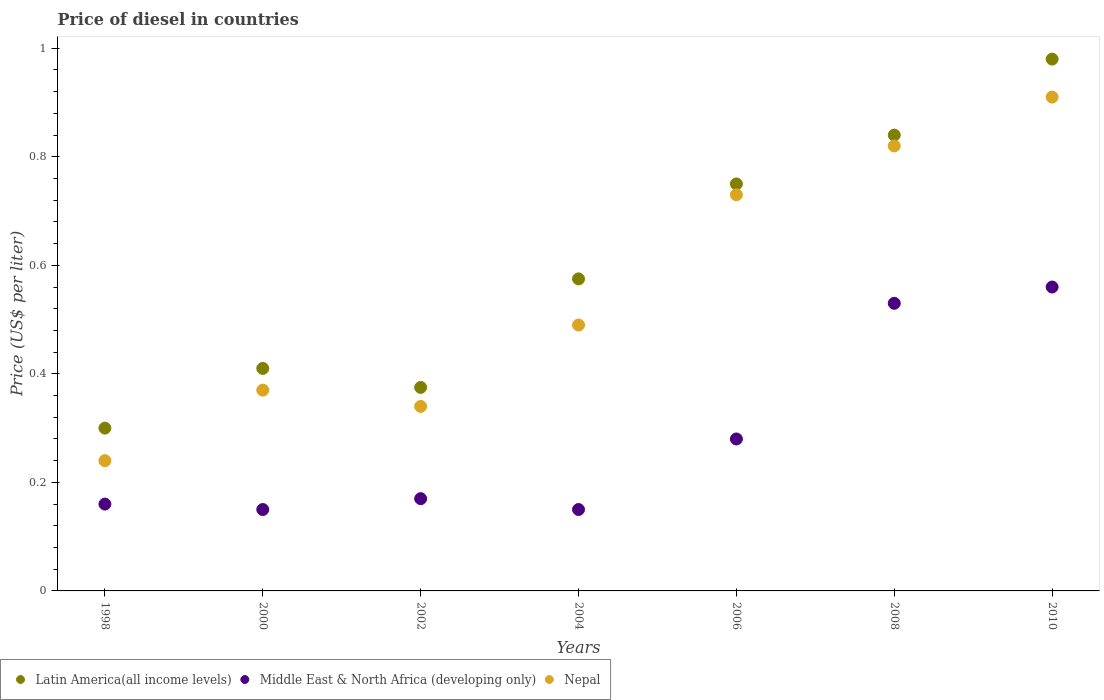How many different coloured dotlines are there?
Give a very brief answer. 3. What is the price of diesel in Middle East & North Africa (developing only) in 2002?
Make the answer very short. 0.17. Across all years, what is the maximum price of diesel in Nepal?
Keep it short and to the point. 0.91. Across all years, what is the minimum price of diesel in Middle East & North Africa (developing only)?
Your answer should be very brief. 0.15. What is the total price of diesel in Latin America(all income levels) in the graph?
Keep it short and to the point. 4.23. What is the difference between the price of diesel in Nepal in 2004 and that in 2006?
Your response must be concise. -0.24. What is the difference between the price of diesel in Middle East & North Africa (developing only) in 2006 and the price of diesel in Nepal in 2000?
Your answer should be very brief. -0.09. What is the average price of diesel in Middle East & North Africa (developing only) per year?
Your answer should be compact. 0.29. In the year 2010, what is the difference between the price of diesel in Middle East & North Africa (developing only) and price of diesel in Latin America(all income levels)?
Ensure brevity in your answer.  -0.42. In how many years, is the price of diesel in Latin America(all income levels) greater than 0.9600000000000001 US$?
Provide a short and direct response. 1. What is the ratio of the price of diesel in Latin America(all income levels) in 1998 to that in 2000?
Give a very brief answer. 0.73. Is the difference between the price of diesel in Middle East & North Africa (developing only) in 2000 and 2008 greater than the difference between the price of diesel in Latin America(all income levels) in 2000 and 2008?
Make the answer very short. Yes. What is the difference between the highest and the second highest price of diesel in Nepal?
Your response must be concise. 0.09. What is the difference between the highest and the lowest price of diesel in Nepal?
Give a very brief answer. 0.67. In how many years, is the price of diesel in Middle East & North Africa (developing only) greater than the average price of diesel in Middle East & North Africa (developing only) taken over all years?
Your response must be concise. 2. How many dotlines are there?
Make the answer very short. 3. Are the values on the major ticks of Y-axis written in scientific E-notation?
Your response must be concise. No. Does the graph contain any zero values?
Offer a very short reply. No. How are the legend labels stacked?
Give a very brief answer. Horizontal. What is the title of the graph?
Your answer should be compact. Price of diesel in countries. What is the label or title of the Y-axis?
Offer a terse response. Price (US$ per liter). What is the Price (US$ per liter) in Latin America(all income levels) in 1998?
Provide a short and direct response. 0.3. What is the Price (US$ per liter) of Middle East & North Africa (developing only) in 1998?
Provide a succinct answer. 0.16. What is the Price (US$ per liter) of Nepal in 1998?
Offer a very short reply. 0.24. What is the Price (US$ per liter) in Latin America(all income levels) in 2000?
Provide a succinct answer. 0.41. What is the Price (US$ per liter) in Nepal in 2000?
Ensure brevity in your answer.  0.37. What is the Price (US$ per liter) of Middle East & North Africa (developing only) in 2002?
Provide a short and direct response. 0.17. What is the Price (US$ per liter) of Nepal in 2002?
Give a very brief answer. 0.34. What is the Price (US$ per liter) of Latin America(all income levels) in 2004?
Your answer should be very brief. 0.57. What is the Price (US$ per liter) in Middle East & North Africa (developing only) in 2004?
Ensure brevity in your answer.  0.15. What is the Price (US$ per liter) of Nepal in 2004?
Offer a very short reply. 0.49. What is the Price (US$ per liter) of Latin America(all income levels) in 2006?
Make the answer very short. 0.75. What is the Price (US$ per liter) of Middle East & North Africa (developing only) in 2006?
Give a very brief answer. 0.28. What is the Price (US$ per liter) in Nepal in 2006?
Offer a very short reply. 0.73. What is the Price (US$ per liter) in Latin America(all income levels) in 2008?
Give a very brief answer. 0.84. What is the Price (US$ per liter) in Middle East & North Africa (developing only) in 2008?
Ensure brevity in your answer.  0.53. What is the Price (US$ per liter) of Nepal in 2008?
Make the answer very short. 0.82. What is the Price (US$ per liter) in Middle East & North Africa (developing only) in 2010?
Offer a very short reply. 0.56. What is the Price (US$ per liter) of Nepal in 2010?
Your answer should be compact. 0.91. Across all years, what is the maximum Price (US$ per liter) of Middle East & North Africa (developing only)?
Provide a succinct answer. 0.56. Across all years, what is the maximum Price (US$ per liter) of Nepal?
Your answer should be compact. 0.91. Across all years, what is the minimum Price (US$ per liter) of Latin America(all income levels)?
Your answer should be very brief. 0.3. Across all years, what is the minimum Price (US$ per liter) of Middle East & North Africa (developing only)?
Give a very brief answer. 0.15. Across all years, what is the minimum Price (US$ per liter) in Nepal?
Your answer should be very brief. 0.24. What is the total Price (US$ per liter) in Latin America(all income levels) in the graph?
Offer a very short reply. 4.23. What is the difference between the Price (US$ per liter) in Latin America(all income levels) in 1998 and that in 2000?
Provide a short and direct response. -0.11. What is the difference between the Price (US$ per liter) in Middle East & North Africa (developing only) in 1998 and that in 2000?
Provide a succinct answer. 0.01. What is the difference between the Price (US$ per liter) of Nepal in 1998 and that in 2000?
Your answer should be very brief. -0.13. What is the difference between the Price (US$ per liter) of Latin America(all income levels) in 1998 and that in 2002?
Offer a terse response. -0.07. What is the difference between the Price (US$ per liter) in Middle East & North Africa (developing only) in 1998 and that in 2002?
Your answer should be compact. -0.01. What is the difference between the Price (US$ per liter) of Latin America(all income levels) in 1998 and that in 2004?
Offer a very short reply. -0.28. What is the difference between the Price (US$ per liter) of Nepal in 1998 and that in 2004?
Offer a very short reply. -0.25. What is the difference between the Price (US$ per liter) in Latin America(all income levels) in 1998 and that in 2006?
Keep it short and to the point. -0.45. What is the difference between the Price (US$ per liter) in Middle East & North Africa (developing only) in 1998 and that in 2006?
Your answer should be compact. -0.12. What is the difference between the Price (US$ per liter) of Nepal in 1998 and that in 2006?
Provide a short and direct response. -0.49. What is the difference between the Price (US$ per liter) in Latin America(all income levels) in 1998 and that in 2008?
Keep it short and to the point. -0.54. What is the difference between the Price (US$ per liter) in Middle East & North Africa (developing only) in 1998 and that in 2008?
Offer a terse response. -0.37. What is the difference between the Price (US$ per liter) in Nepal in 1998 and that in 2008?
Give a very brief answer. -0.58. What is the difference between the Price (US$ per liter) in Latin America(all income levels) in 1998 and that in 2010?
Provide a succinct answer. -0.68. What is the difference between the Price (US$ per liter) in Middle East & North Africa (developing only) in 1998 and that in 2010?
Offer a very short reply. -0.4. What is the difference between the Price (US$ per liter) in Nepal in 1998 and that in 2010?
Keep it short and to the point. -0.67. What is the difference between the Price (US$ per liter) of Latin America(all income levels) in 2000 and that in 2002?
Your response must be concise. 0.04. What is the difference between the Price (US$ per liter) of Middle East & North Africa (developing only) in 2000 and that in 2002?
Provide a succinct answer. -0.02. What is the difference between the Price (US$ per liter) of Nepal in 2000 and that in 2002?
Offer a terse response. 0.03. What is the difference between the Price (US$ per liter) of Latin America(all income levels) in 2000 and that in 2004?
Make the answer very short. -0.17. What is the difference between the Price (US$ per liter) in Middle East & North Africa (developing only) in 2000 and that in 2004?
Offer a very short reply. 0. What is the difference between the Price (US$ per liter) of Nepal in 2000 and that in 2004?
Give a very brief answer. -0.12. What is the difference between the Price (US$ per liter) in Latin America(all income levels) in 2000 and that in 2006?
Ensure brevity in your answer.  -0.34. What is the difference between the Price (US$ per liter) in Middle East & North Africa (developing only) in 2000 and that in 2006?
Your answer should be very brief. -0.13. What is the difference between the Price (US$ per liter) in Nepal in 2000 and that in 2006?
Offer a terse response. -0.36. What is the difference between the Price (US$ per liter) in Latin America(all income levels) in 2000 and that in 2008?
Offer a terse response. -0.43. What is the difference between the Price (US$ per liter) of Middle East & North Africa (developing only) in 2000 and that in 2008?
Offer a very short reply. -0.38. What is the difference between the Price (US$ per liter) of Nepal in 2000 and that in 2008?
Offer a very short reply. -0.45. What is the difference between the Price (US$ per liter) of Latin America(all income levels) in 2000 and that in 2010?
Your response must be concise. -0.57. What is the difference between the Price (US$ per liter) in Middle East & North Africa (developing only) in 2000 and that in 2010?
Ensure brevity in your answer.  -0.41. What is the difference between the Price (US$ per liter) of Nepal in 2000 and that in 2010?
Provide a succinct answer. -0.54. What is the difference between the Price (US$ per liter) in Middle East & North Africa (developing only) in 2002 and that in 2004?
Offer a very short reply. 0.02. What is the difference between the Price (US$ per liter) in Nepal in 2002 and that in 2004?
Give a very brief answer. -0.15. What is the difference between the Price (US$ per liter) in Latin America(all income levels) in 2002 and that in 2006?
Provide a succinct answer. -0.38. What is the difference between the Price (US$ per liter) in Middle East & North Africa (developing only) in 2002 and that in 2006?
Offer a terse response. -0.11. What is the difference between the Price (US$ per liter) in Nepal in 2002 and that in 2006?
Provide a short and direct response. -0.39. What is the difference between the Price (US$ per liter) in Latin America(all income levels) in 2002 and that in 2008?
Provide a short and direct response. -0.47. What is the difference between the Price (US$ per liter) of Middle East & North Africa (developing only) in 2002 and that in 2008?
Offer a terse response. -0.36. What is the difference between the Price (US$ per liter) in Nepal in 2002 and that in 2008?
Your response must be concise. -0.48. What is the difference between the Price (US$ per liter) in Latin America(all income levels) in 2002 and that in 2010?
Make the answer very short. -0.6. What is the difference between the Price (US$ per liter) of Middle East & North Africa (developing only) in 2002 and that in 2010?
Keep it short and to the point. -0.39. What is the difference between the Price (US$ per liter) in Nepal in 2002 and that in 2010?
Provide a succinct answer. -0.57. What is the difference between the Price (US$ per liter) of Latin America(all income levels) in 2004 and that in 2006?
Your answer should be very brief. -0.17. What is the difference between the Price (US$ per liter) in Middle East & North Africa (developing only) in 2004 and that in 2006?
Your response must be concise. -0.13. What is the difference between the Price (US$ per liter) in Nepal in 2004 and that in 2006?
Give a very brief answer. -0.24. What is the difference between the Price (US$ per liter) in Latin America(all income levels) in 2004 and that in 2008?
Your answer should be very brief. -0.27. What is the difference between the Price (US$ per liter) in Middle East & North Africa (developing only) in 2004 and that in 2008?
Ensure brevity in your answer.  -0.38. What is the difference between the Price (US$ per liter) in Nepal in 2004 and that in 2008?
Keep it short and to the point. -0.33. What is the difference between the Price (US$ per liter) in Latin America(all income levels) in 2004 and that in 2010?
Your answer should be compact. -0.41. What is the difference between the Price (US$ per liter) of Middle East & North Africa (developing only) in 2004 and that in 2010?
Offer a very short reply. -0.41. What is the difference between the Price (US$ per liter) of Nepal in 2004 and that in 2010?
Offer a terse response. -0.42. What is the difference between the Price (US$ per liter) of Latin America(all income levels) in 2006 and that in 2008?
Give a very brief answer. -0.09. What is the difference between the Price (US$ per liter) of Nepal in 2006 and that in 2008?
Your answer should be compact. -0.09. What is the difference between the Price (US$ per liter) of Latin America(all income levels) in 2006 and that in 2010?
Provide a succinct answer. -0.23. What is the difference between the Price (US$ per liter) of Middle East & North Africa (developing only) in 2006 and that in 2010?
Your response must be concise. -0.28. What is the difference between the Price (US$ per liter) of Nepal in 2006 and that in 2010?
Your answer should be very brief. -0.18. What is the difference between the Price (US$ per liter) in Latin America(all income levels) in 2008 and that in 2010?
Offer a terse response. -0.14. What is the difference between the Price (US$ per liter) in Middle East & North Africa (developing only) in 2008 and that in 2010?
Provide a succinct answer. -0.03. What is the difference between the Price (US$ per liter) in Nepal in 2008 and that in 2010?
Offer a very short reply. -0.09. What is the difference between the Price (US$ per liter) in Latin America(all income levels) in 1998 and the Price (US$ per liter) in Nepal in 2000?
Make the answer very short. -0.07. What is the difference between the Price (US$ per liter) of Middle East & North Africa (developing only) in 1998 and the Price (US$ per liter) of Nepal in 2000?
Provide a short and direct response. -0.21. What is the difference between the Price (US$ per liter) of Latin America(all income levels) in 1998 and the Price (US$ per liter) of Middle East & North Africa (developing only) in 2002?
Make the answer very short. 0.13. What is the difference between the Price (US$ per liter) in Latin America(all income levels) in 1998 and the Price (US$ per liter) in Nepal in 2002?
Ensure brevity in your answer.  -0.04. What is the difference between the Price (US$ per liter) in Middle East & North Africa (developing only) in 1998 and the Price (US$ per liter) in Nepal in 2002?
Your answer should be compact. -0.18. What is the difference between the Price (US$ per liter) of Latin America(all income levels) in 1998 and the Price (US$ per liter) of Nepal in 2004?
Your answer should be very brief. -0.19. What is the difference between the Price (US$ per liter) in Middle East & North Africa (developing only) in 1998 and the Price (US$ per liter) in Nepal in 2004?
Provide a succinct answer. -0.33. What is the difference between the Price (US$ per liter) of Latin America(all income levels) in 1998 and the Price (US$ per liter) of Nepal in 2006?
Make the answer very short. -0.43. What is the difference between the Price (US$ per liter) in Middle East & North Africa (developing only) in 1998 and the Price (US$ per liter) in Nepal in 2006?
Provide a succinct answer. -0.57. What is the difference between the Price (US$ per liter) of Latin America(all income levels) in 1998 and the Price (US$ per liter) of Middle East & North Africa (developing only) in 2008?
Give a very brief answer. -0.23. What is the difference between the Price (US$ per liter) of Latin America(all income levels) in 1998 and the Price (US$ per liter) of Nepal in 2008?
Offer a terse response. -0.52. What is the difference between the Price (US$ per liter) in Middle East & North Africa (developing only) in 1998 and the Price (US$ per liter) in Nepal in 2008?
Ensure brevity in your answer.  -0.66. What is the difference between the Price (US$ per liter) in Latin America(all income levels) in 1998 and the Price (US$ per liter) in Middle East & North Africa (developing only) in 2010?
Offer a terse response. -0.26. What is the difference between the Price (US$ per liter) of Latin America(all income levels) in 1998 and the Price (US$ per liter) of Nepal in 2010?
Keep it short and to the point. -0.61. What is the difference between the Price (US$ per liter) in Middle East & North Africa (developing only) in 1998 and the Price (US$ per liter) in Nepal in 2010?
Give a very brief answer. -0.75. What is the difference between the Price (US$ per liter) of Latin America(all income levels) in 2000 and the Price (US$ per liter) of Middle East & North Africa (developing only) in 2002?
Your answer should be compact. 0.24. What is the difference between the Price (US$ per liter) of Latin America(all income levels) in 2000 and the Price (US$ per liter) of Nepal in 2002?
Give a very brief answer. 0.07. What is the difference between the Price (US$ per liter) in Middle East & North Africa (developing only) in 2000 and the Price (US$ per liter) in Nepal in 2002?
Make the answer very short. -0.19. What is the difference between the Price (US$ per liter) of Latin America(all income levels) in 2000 and the Price (US$ per liter) of Middle East & North Africa (developing only) in 2004?
Offer a terse response. 0.26. What is the difference between the Price (US$ per liter) of Latin America(all income levels) in 2000 and the Price (US$ per liter) of Nepal in 2004?
Offer a very short reply. -0.08. What is the difference between the Price (US$ per liter) of Middle East & North Africa (developing only) in 2000 and the Price (US$ per liter) of Nepal in 2004?
Your answer should be compact. -0.34. What is the difference between the Price (US$ per liter) in Latin America(all income levels) in 2000 and the Price (US$ per liter) in Middle East & North Africa (developing only) in 2006?
Offer a terse response. 0.13. What is the difference between the Price (US$ per liter) in Latin America(all income levels) in 2000 and the Price (US$ per liter) in Nepal in 2006?
Make the answer very short. -0.32. What is the difference between the Price (US$ per liter) of Middle East & North Africa (developing only) in 2000 and the Price (US$ per liter) of Nepal in 2006?
Your answer should be very brief. -0.58. What is the difference between the Price (US$ per liter) in Latin America(all income levels) in 2000 and the Price (US$ per liter) in Middle East & North Africa (developing only) in 2008?
Your answer should be compact. -0.12. What is the difference between the Price (US$ per liter) in Latin America(all income levels) in 2000 and the Price (US$ per liter) in Nepal in 2008?
Your answer should be compact. -0.41. What is the difference between the Price (US$ per liter) of Middle East & North Africa (developing only) in 2000 and the Price (US$ per liter) of Nepal in 2008?
Make the answer very short. -0.67. What is the difference between the Price (US$ per liter) in Latin America(all income levels) in 2000 and the Price (US$ per liter) in Nepal in 2010?
Offer a very short reply. -0.5. What is the difference between the Price (US$ per liter) in Middle East & North Africa (developing only) in 2000 and the Price (US$ per liter) in Nepal in 2010?
Your answer should be very brief. -0.76. What is the difference between the Price (US$ per liter) of Latin America(all income levels) in 2002 and the Price (US$ per liter) of Middle East & North Africa (developing only) in 2004?
Offer a very short reply. 0.23. What is the difference between the Price (US$ per liter) of Latin America(all income levels) in 2002 and the Price (US$ per liter) of Nepal in 2004?
Make the answer very short. -0.12. What is the difference between the Price (US$ per liter) in Middle East & North Africa (developing only) in 2002 and the Price (US$ per liter) in Nepal in 2004?
Offer a very short reply. -0.32. What is the difference between the Price (US$ per liter) of Latin America(all income levels) in 2002 and the Price (US$ per liter) of Middle East & North Africa (developing only) in 2006?
Give a very brief answer. 0.1. What is the difference between the Price (US$ per liter) in Latin America(all income levels) in 2002 and the Price (US$ per liter) in Nepal in 2006?
Provide a short and direct response. -0.35. What is the difference between the Price (US$ per liter) in Middle East & North Africa (developing only) in 2002 and the Price (US$ per liter) in Nepal in 2006?
Provide a succinct answer. -0.56. What is the difference between the Price (US$ per liter) of Latin America(all income levels) in 2002 and the Price (US$ per liter) of Middle East & North Africa (developing only) in 2008?
Offer a very short reply. -0.15. What is the difference between the Price (US$ per liter) in Latin America(all income levels) in 2002 and the Price (US$ per liter) in Nepal in 2008?
Give a very brief answer. -0.45. What is the difference between the Price (US$ per liter) of Middle East & North Africa (developing only) in 2002 and the Price (US$ per liter) of Nepal in 2008?
Your answer should be compact. -0.65. What is the difference between the Price (US$ per liter) of Latin America(all income levels) in 2002 and the Price (US$ per liter) of Middle East & North Africa (developing only) in 2010?
Provide a succinct answer. -0.18. What is the difference between the Price (US$ per liter) in Latin America(all income levels) in 2002 and the Price (US$ per liter) in Nepal in 2010?
Ensure brevity in your answer.  -0.54. What is the difference between the Price (US$ per liter) in Middle East & North Africa (developing only) in 2002 and the Price (US$ per liter) in Nepal in 2010?
Ensure brevity in your answer.  -0.74. What is the difference between the Price (US$ per liter) in Latin America(all income levels) in 2004 and the Price (US$ per liter) in Middle East & North Africa (developing only) in 2006?
Your answer should be compact. 0.29. What is the difference between the Price (US$ per liter) of Latin America(all income levels) in 2004 and the Price (US$ per liter) of Nepal in 2006?
Offer a terse response. -0.15. What is the difference between the Price (US$ per liter) of Middle East & North Africa (developing only) in 2004 and the Price (US$ per liter) of Nepal in 2006?
Offer a terse response. -0.58. What is the difference between the Price (US$ per liter) in Latin America(all income levels) in 2004 and the Price (US$ per liter) in Middle East & North Africa (developing only) in 2008?
Give a very brief answer. 0.04. What is the difference between the Price (US$ per liter) of Latin America(all income levels) in 2004 and the Price (US$ per liter) of Nepal in 2008?
Your answer should be very brief. -0.24. What is the difference between the Price (US$ per liter) in Middle East & North Africa (developing only) in 2004 and the Price (US$ per liter) in Nepal in 2008?
Provide a succinct answer. -0.67. What is the difference between the Price (US$ per liter) in Latin America(all income levels) in 2004 and the Price (US$ per liter) in Middle East & North Africa (developing only) in 2010?
Make the answer very short. 0.01. What is the difference between the Price (US$ per liter) of Latin America(all income levels) in 2004 and the Price (US$ per liter) of Nepal in 2010?
Offer a very short reply. -0.34. What is the difference between the Price (US$ per liter) of Middle East & North Africa (developing only) in 2004 and the Price (US$ per liter) of Nepal in 2010?
Ensure brevity in your answer.  -0.76. What is the difference between the Price (US$ per liter) of Latin America(all income levels) in 2006 and the Price (US$ per liter) of Middle East & North Africa (developing only) in 2008?
Your answer should be compact. 0.22. What is the difference between the Price (US$ per liter) in Latin America(all income levels) in 2006 and the Price (US$ per liter) in Nepal in 2008?
Make the answer very short. -0.07. What is the difference between the Price (US$ per liter) of Middle East & North Africa (developing only) in 2006 and the Price (US$ per liter) of Nepal in 2008?
Ensure brevity in your answer.  -0.54. What is the difference between the Price (US$ per liter) in Latin America(all income levels) in 2006 and the Price (US$ per liter) in Middle East & North Africa (developing only) in 2010?
Ensure brevity in your answer.  0.19. What is the difference between the Price (US$ per liter) in Latin America(all income levels) in 2006 and the Price (US$ per liter) in Nepal in 2010?
Offer a very short reply. -0.16. What is the difference between the Price (US$ per liter) of Middle East & North Africa (developing only) in 2006 and the Price (US$ per liter) of Nepal in 2010?
Your answer should be compact. -0.63. What is the difference between the Price (US$ per liter) of Latin America(all income levels) in 2008 and the Price (US$ per liter) of Middle East & North Africa (developing only) in 2010?
Your answer should be compact. 0.28. What is the difference between the Price (US$ per liter) in Latin America(all income levels) in 2008 and the Price (US$ per liter) in Nepal in 2010?
Offer a very short reply. -0.07. What is the difference between the Price (US$ per liter) in Middle East & North Africa (developing only) in 2008 and the Price (US$ per liter) in Nepal in 2010?
Your answer should be compact. -0.38. What is the average Price (US$ per liter) in Latin America(all income levels) per year?
Make the answer very short. 0.6. What is the average Price (US$ per liter) in Middle East & North Africa (developing only) per year?
Provide a short and direct response. 0.29. What is the average Price (US$ per liter) in Nepal per year?
Keep it short and to the point. 0.56. In the year 1998, what is the difference between the Price (US$ per liter) of Latin America(all income levels) and Price (US$ per liter) of Middle East & North Africa (developing only)?
Give a very brief answer. 0.14. In the year 1998, what is the difference between the Price (US$ per liter) in Middle East & North Africa (developing only) and Price (US$ per liter) in Nepal?
Ensure brevity in your answer.  -0.08. In the year 2000, what is the difference between the Price (US$ per liter) in Latin America(all income levels) and Price (US$ per liter) in Middle East & North Africa (developing only)?
Make the answer very short. 0.26. In the year 2000, what is the difference between the Price (US$ per liter) in Middle East & North Africa (developing only) and Price (US$ per liter) in Nepal?
Provide a short and direct response. -0.22. In the year 2002, what is the difference between the Price (US$ per liter) in Latin America(all income levels) and Price (US$ per liter) in Middle East & North Africa (developing only)?
Give a very brief answer. 0.2. In the year 2002, what is the difference between the Price (US$ per liter) in Latin America(all income levels) and Price (US$ per liter) in Nepal?
Provide a succinct answer. 0.04. In the year 2002, what is the difference between the Price (US$ per liter) of Middle East & North Africa (developing only) and Price (US$ per liter) of Nepal?
Your answer should be very brief. -0.17. In the year 2004, what is the difference between the Price (US$ per liter) in Latin America(all income levels) and Price (US$ per liter) in Middle East & North Africa (developing only)?
Ensure brevity in your answer.  0.42. In the year 2004, what is the difference between the Price (US$ per liter) in Latin America(all income levels) and Price (US$ per liter) in Nepal?
Your answer should be very brief. 0.09. In the year 2004, what is the difference between the Price (US$ per liter) of Middle East & North Africa (developing only) and Price (US$ per liter) of Nepal?
Offer a very short reply. -0.34. In the year 2006, what is the difference between the Price (US$ per liter) in Latin America(all income levels) and Price (US$ per liter) in Middle East & North Africa (developing only)?
Offer a very short reply. 0.47. In the year 2006, what is the difference between the Price (US$ per liter) in Middle East & North Africa (developing only) and Price (US$ per liter) in Nepal?
Keep it short and to the point. -0.45. In the year 2008, what is the difference between the Price (US$ per liter) of Latin America(all income levels) and Price (US$ per liter) of Middle East & North Africa (developing only)?
Your answer should be very brief. 0.31. In the year 2008, what is the difference between the Price (US$ per liter) of Latin America(all income levels) and Price (US$ per liter) of Nepal?
Ensure brevity in your answer.  0.02. In the year 2008, what is the difference between the Price (US$ per liter) in Middle East & North Africa (developing only) and Price (US$ per liter) in Nepal?
Your answer should be compact. -0.29. In the year 2010, what is the difference between the Price (US$ per liter) of Latin America(all income levels) and Price (US$ per liter) of Middle East & North Africa (developing only)?
Ensure brevity in your answer.  0.42. In the year 2010, what is the difference between the Price (US$ per liter) of Latin America(all income levels) and Price (US$ per liter) of Nepal?
Keep it short and to the point. 0.07. In the year 2010, what is the difference between the Price (US$ per liter) in Middle East & North Africa (developing only) and Price (US$ per liter) in Nepal?
Provide a succinct answer. -0.35. What is the ratio of the Price (US$ per liter) of Latin America(all income levels) in 1998 to that in 2000?
Make the answer very short. 0.73. What is the ratio of the Price (US$ per liter) of Middle East & North Africa (developing only) in 1998 to that in 2000?
Offer a terse response. 1.07. What is the ratio of the Price (US$ per liter) of Nepal in 1998 to that in 2000?
Offer a very short reply. 0.65. What is the ratio of the Price (US$ per liter) of Nepal in 1998 to that in 2002?
Give a very brief answer. 0.71. What is the ratio of the Price (US$ per liter) of Latin America(all income levels) in 1998 to that in 2004?
Provide a succinct answer. 0.52. What is the ratio of the Price (US$ per liter) of Middle East & North Africa (developing only) in 1998 to that in 2004?
Keep it short and to the point. 1.07. What is the ratio of the Price (US$ per liter) in Nepal in 1998 to that in 2004?
Provide a succinct answer. 0.49. What is the ratio of the Price (US$ per liter) of Latin America(all income levels) in 1998 to that in 2006?
Your answer should be very brief. 0.4. What is the ratio of the Price (US$ per liter) in Nepal in 1998 to that in 2006?
Make the answer very short. 0.33. What is the ratio of the Price (US$ per liter) of Latin America(all income levels) in 1998 to that in 2008?
Make the answer very short. 0.36. What is the ratio of the Price (US$ per liter) in Middle East & North Africa (developing only) in 1998 to that in 2008?
Keep it short and to the point. 0.3. What is the ratio of the Price (US$ per liter) of Nepal in 1998 to that in 2008?
Keep it short and to the point. 0.29. What is the ratio of the Price (US$ per liter) in Latin America(all income levels) in 1998 to that in 2010?
Give a very brief answer. 0.31. What is the ratio of the Price (US$ per liter) of Middle East & North Africa (developing only) in 1998 to that in 2010?
Your response must be concise. 0.29. What is the ratio of the Price (US$ per liter) in Nepal in 1998 to that in 2010?
Your answer should be compact. 0.26. What is the ratio of the Price (US$ per liter) in Latin America(all income levels) in 2000 to that in 2002?
Provide a succinct answer. 1.09. What is the ratio of the Price (US$ per liter) in Middle East & North Africa (developing only) in 2000 to that in 2002?
Your answer should be compact. 0.88. What is the ratio of the Price (US$ per liter) in Nepal in 2000 to that in 2002?
Offer a very short reply. 1.09. What is the ratio of the Price (US$ per liter) in Latin America(all income levels) in 2000 to that in 2004?
Provide a succinct answer. 0.71. What is the ratio of the Price (US$ per liter) in Middle East & North Africa (developing only) in 2000 to that in 2004?
Offer a very short reply. 1. What is the ratio of the Price (US$ per liter) of Nepal in 2000 to that in 2004?
Offer a terse response. 0.76. What is the ratio of the Price (US$ per liter) of Latin America(all income levels) in 2000 to that in 2006?
Give a very brief answer. 0.55. What is the ratio of the Price (US$ per liter) of Middle East & North Africa (developing only) in 2000 to that in 2006?
Provide a short and direct response. 0.54. What is the ratio of the Price (US$ per liter) of Nepal in 2000 to that in 2006?
Give a very brief answer. 0.51. What is the ratio of the Price (US$ per liter) in Latin America(all income levels) in 2000 to that in 2008?
Give a very brief answer. 0.49. What is the ratio of the Price (US$ per liter) in Middle East & North Africa (developing only) in 2000 to that in 2008?
Your answer should be compact. 0.28. What is the ratio of the Price (US$ per liter) in Nepal in 2000 to that in 2008?
Ensure brevity in your answer.  0.45. What is the ratio of the Price (US$ per liter) of Latin America(all income levels) in 2000 to that in 2010?
Make the answer very short. 0.42. What is the ratio of the Price (US$ per liter) of Middle East & North Africa (developing only) in 2000 to that in 2010?
Provide a succinct answer. 0.27. What is the ratio of the Price (US$ per liter) of Nepal in 2000 to that in 2010?
Ensure brevity in your answer.  0.41. What is the ratio of the Price (US$ per liter) of Latin America(all income levels) in 2002 to that in 2004?
Provide a short and direct response. 0.65. What is the ratio of the Price (US$ per liter) of Middle East & North Africa (developing only) in 2002 to that in 2004?
Provide a short and direct response. 1.13. What is the ratio of the Price (US$ per liter) in Nepal in 2002 to that in 2004?
Your answer should be compact. 0.69. What is the ratio of the Price (US$ per liter) in Latin America(all income levels) in 2002 to that in 2006?
Make the answer very short. 0.5. What is the ratio of the Price (US$ per liter) in Middle East & North Africa (developing only) in 2002 to that in 2006?
Make the answer very short. 0.61. What is the ratio of the Price (US$ per liter) of Nepal in 2002 to that in 2006?
Make the answer very short. 0.47. What is the ratio of the Price (US$ per liter) of Latin America(all income levels) in 2002 to that in 2008?
Your answer should be compact. 0.45. What is the ratio of the Price (US$ per liter) of Middle East & North Africa (developing only) in 2002 to that in 2008?
Ensure brevity in your answer.  0.32. What is the ratio of the Price (US$ per liter) in Nepal in 2002 to that in 2008?
Offer a terse response. 0.41. What is the ratio of the Price (US$ per liter) in Latin America(all income levels) in 2002 to that in 2010?
Make the answer very short. 0.38. What is the ratio of the Price (US$ per liter) of Middle East & North Africa (developing only) in 2002 to that in 2010?
Give a very brief answer. 0.3. What is the ratio of the Price (US$ per liter) of Nepal in 2002 to that in 2010?
Make the answer very short. 0.37. What is the ratio of the Price (US$ per liter) in Latin America(all income levels) in 2004 to that in 2006?
Give a very brief answer. 0.77. What is the ratio of the Price (US$ per liter) of Middle East & North Africa (developing only) in 2004 to that in 2006?
Provide a short and direct response. 0.54. What is the ratio of the Price (US$ per liter) in Nepal in 2004 to that in 2006?
Provide a short and direct response. 0.67. What is the ratio of the Price (US$ per liter) of Latin America(all income levels) in 2004 to that in 2008?
Keep it short and to the point. 0.68. What is the ratio of the Price (US$ per liter) in Middle East & North Africa (developing only) in 2004 to that in 2008?
Your response must be concise. 0.28. What is the ratio of the Price (US$ per liter) in Nepal in 2004 to that in 2008?
Your response must be concise. 0.6. What is the ratio of the Price (US$ per liter) in Latin America(all income levels) in 2004 to that in 2010?
Your response must be concise. 0.59. What is the ratio of the Price (US$ per liter) of Middle East & North Africa (developing only) in 2004 to that in 2010?
Keep it short and to the point. 0.27. What is the ratio of the Price (US$ per liter) of Nepal in 2004 to that in 2010?
Keep it short and to the point. 0.54. What is the ratio of the Price (US$ per liter) in Latin America(all income levels) in 2006 to that in 2008?
Make the answer very short. 0.89. What is the ratio of the Price (US$ per liter) of Middle East & North Africa (developing only) in 2006 to that in 2008?
Make the answer very short. 0.53. What is the ratio of the Price (US$ per liter) of Nepal in 2006 to that in 2008?
Offer a terse response. 0.89. What is the ratio of the Price (US$ per liter) in Latin America(all income levels) in 2006 to that in 2010?
Your response must be concise. 0.77. What is the ratio of the Price (US$ per liter) of Middle East & North Africa (developing only) in 2006 to that in 2010?
Provide a short and direct response. 0.5. What is the ratio of the Price (US$ per liter) of Nepal in 2006 to that in 2010?
Provide a succinct answer. 0.8. What is the ratio of the Price (US$ per liter) of Middle East & North Africa (developing only) in 2008 to that in 2010?
Keep it short and to the point. 0.95. What is the ratio of the Price (US$ per liter) in Nepal in 2008 to that in 2010?
Offer a terse response. 0.9. What is the difference between the highest and the second highest Price (US$ per liter) in Latin America(all income levels)?
Ensure brevity in your answer.  0.14. What is the difference between the highest and the second highest Price (US$ per liter) in Middle East & North Africa (developing only)?
Offer a terse response. 0.03. What is the difference between the highest and the second highest Price (US$ per liter) in Nepal?
Give a very brief answer. 0.09. What is the difference between the highest and the lowest Price (US$ per liter) of Latin America(all income levels)?
Your answer should be very brief. 0.68. What is the difference between the highest and the lowest Price (US$ per liter) of Middle East & North Africa (developing only)?
Provide a succinct answer. 0.41. What is the difference between the highest and the lowest Price (US$ per liter) in Nepal?
Give a very brief answer. 0.67. 